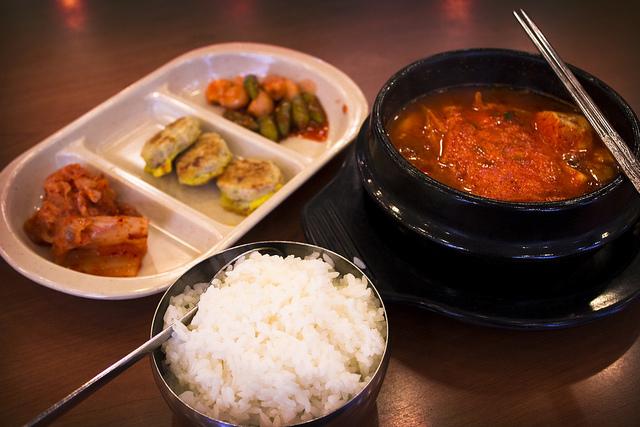Is the white food fried?
Keep it brief. No. What is in the blue bowl on the right?
Give a very brief answer. Soup. What is in the black bowl?
Answer briefly. Soup. How many sections are in the plate?
Concise answer only. 3. 